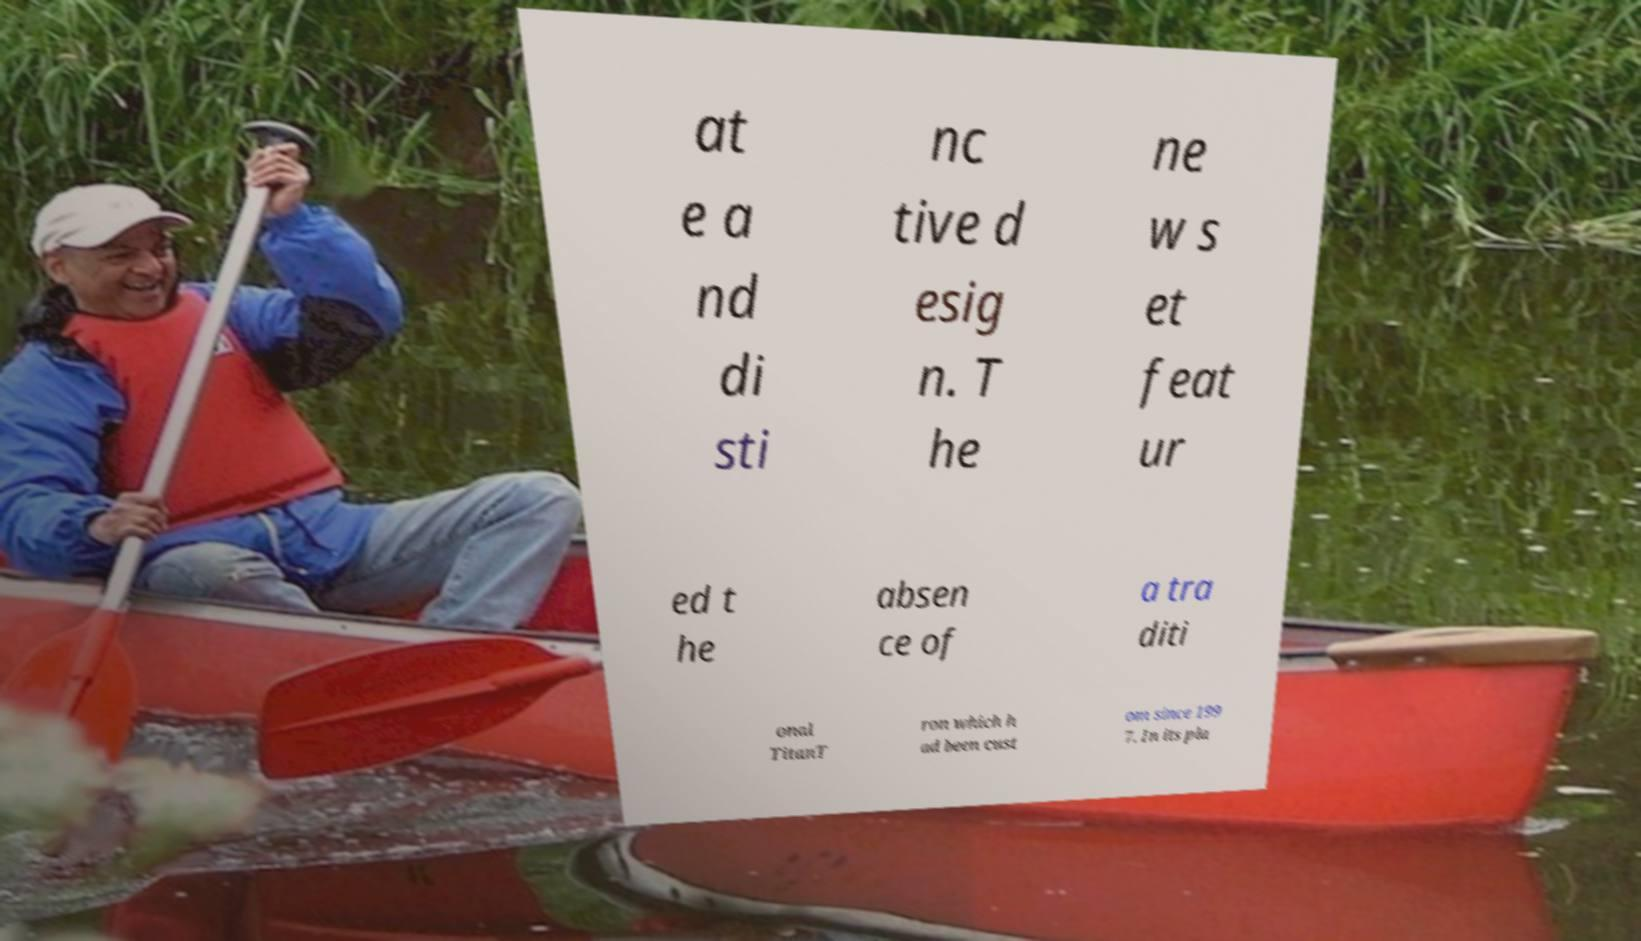I need the written content from this picture converted into text. Can you do that? at e a nd di sti nc tive d esig n. T he ne w s et feat ur ed t he absen ce of a tra diti onal TitanT ron which h ad been cust om since 199 7. In its pla 